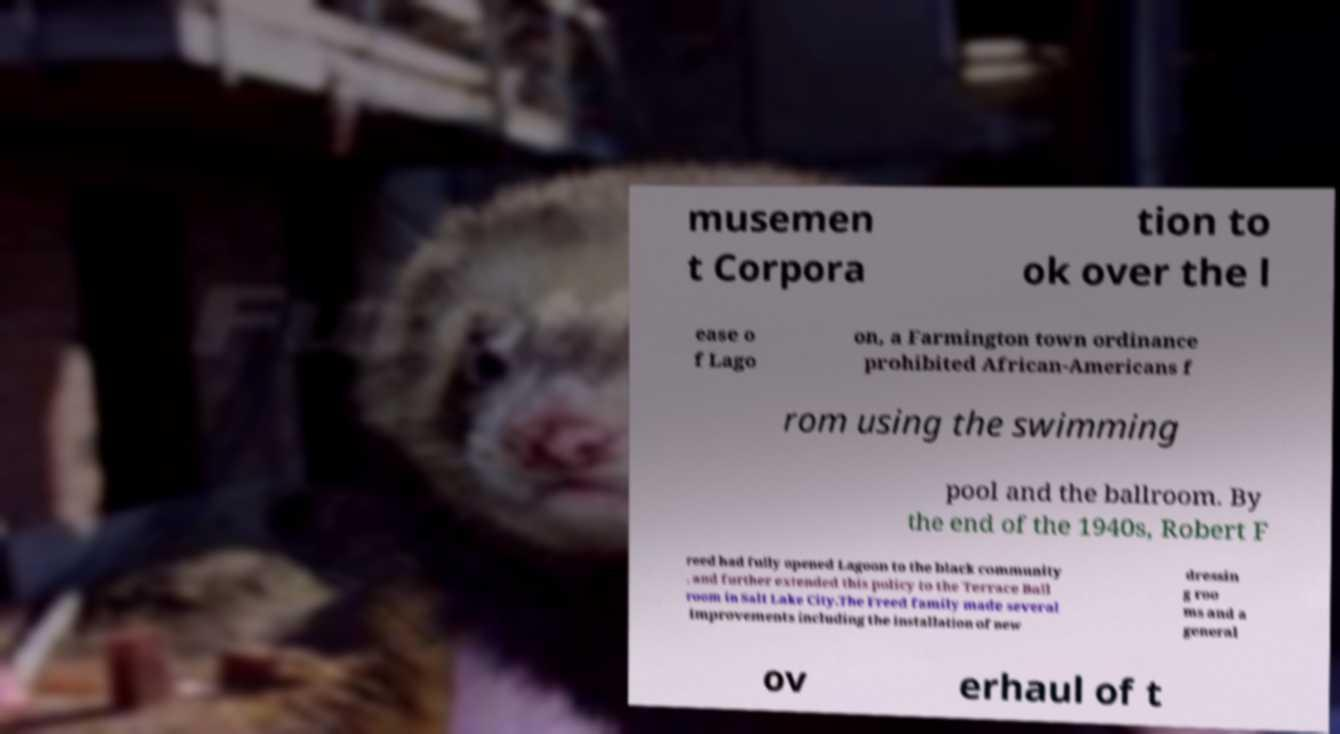For documentation purposes, I need the text within this image transcribed. Could you provide that? musemen t Corpora tion to ok over the l ease o f Lago on, a Farmington town ordinance prohibited African-Americans f rom using the swimming pool and the ballroom. By the end of the 1940s, Robert F reed had fully opened Lagoon to the black community , and further extended this policy to the Terrace Ball room in Salt Lake City.The Freed family made several improvements including the installation of new dressin g roo ms and a general ov erhaul of t 